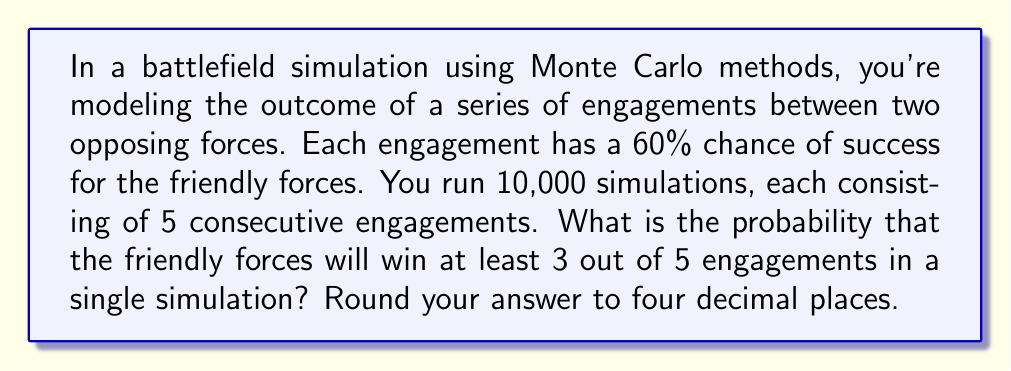Can you solve this math problem? To solve this problem, we'll use the binomial probability distribution and Monte Carlo simulation concepts:

1) Each engagement is a Bernoulli trial with p = 0.6 (60% chance of success).

2) We need to calculate P(X ≥ 3), where X is the number of successful engagements out of 5.

3) This can be calculated as:
   P(X ≥ 3) = P(X = 3) + P(X = 4) + P(X = 5)

4) Using the binomial probability formula:
   $$P(X = k) = \binom{n}{k} p^k (1-p)^{n-k}$$
   where n = 5, p = 0.6, and k = 3, 4, or 5

5) Let's calculate each probability:

   For k = 3:
   $$P(X = 3) = \binom{5}{3} (0.6)^3 (0.4)^2 = 10 * 0.216 * 0.16 = 0.3456$$

   For k = 4:
   $$P(X = 4) = \binom{5}{4} (0.6)^4 (0.4)^1 = 5 * 0.1296 * 0.4 = 0.2592$$

   For k = 5:
   $$P(X = 5) = \binom{5}{5} (0.6)^5 (0.4)^0 = 1 * 0.07776 * 1 = 0.07776$$

6) Sum these probabilities:
   P(X ≥ 3) = 0.3456 + 0.2592 + 0.07776 = 0.68256

7) Rounding to four decimal places: 0.6826

Note: The large number of simulations (10,000) ensures that our Monte Carlo estimate will be close to this theoretical probability.
Answer: 0.6826 